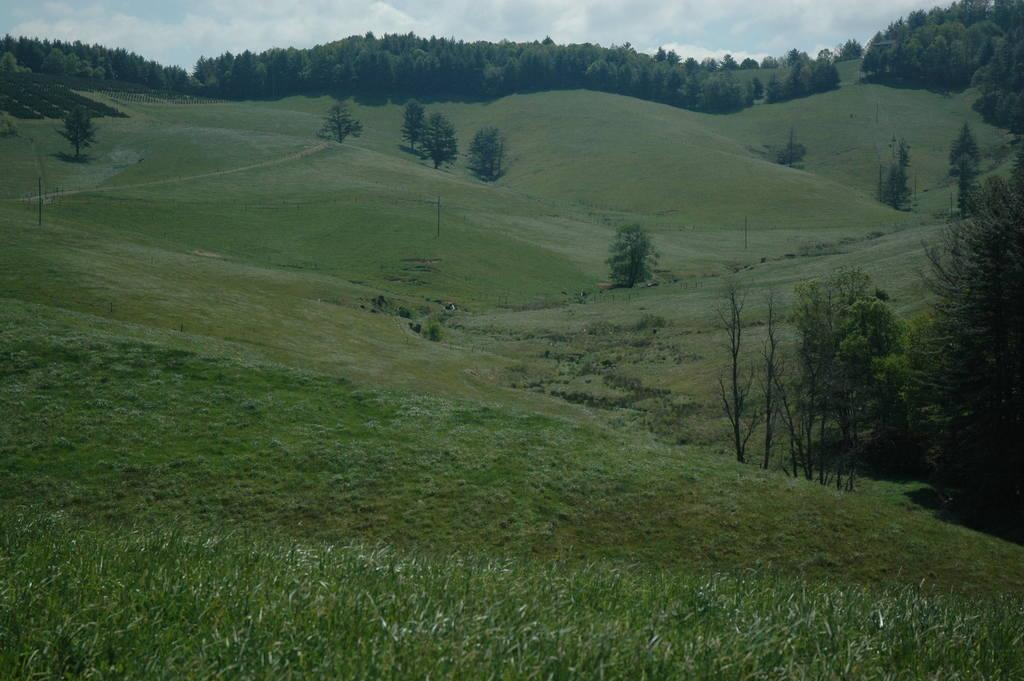What type of landscape is depicted in the image? The image features hills. What other natural elements can be seen in the image? There are trees and grass visible in the image. What is visible in the sky at the top of the image? Clouds are present in the sky at the top of the image. Where is the faucet located in the image? There is no faucet present in the image. What type of trousers are the trees wearing in the image? Trees do not wear trousers; they are plants. 